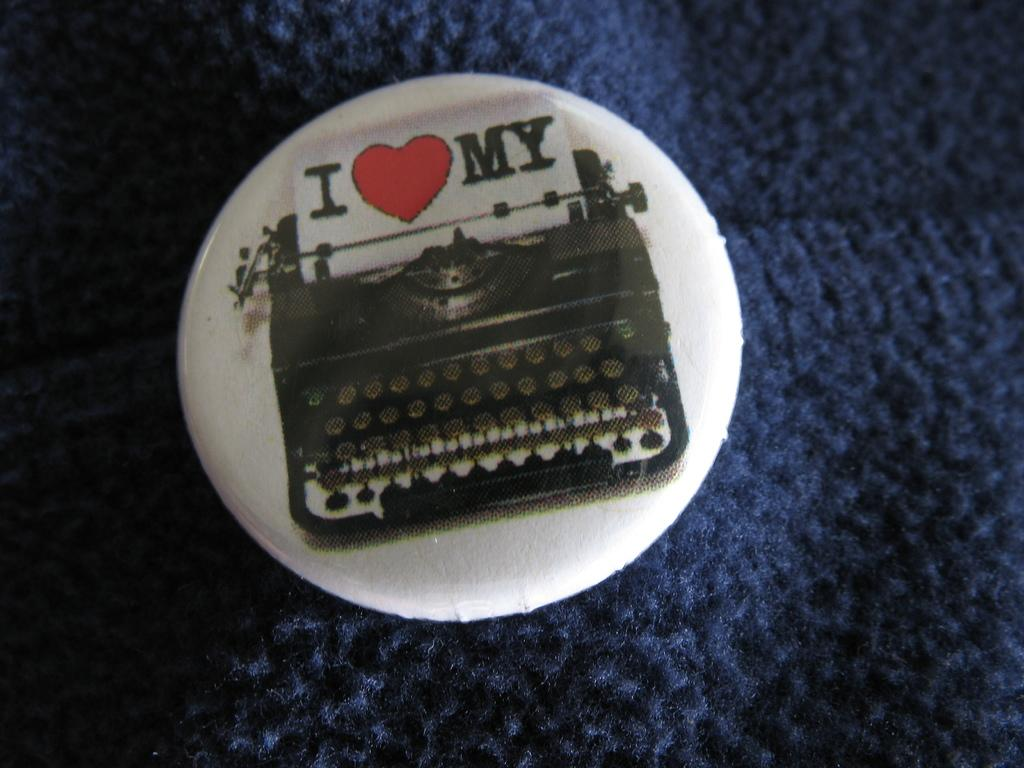What is the main object in the image? There is a badge in the image. What is depicted on the badge? The badge has a typewriter image on it. How many leaves are on the typewriter in the image? There are no leaves present in the image, as it features a badge with a typewriter image on it. 